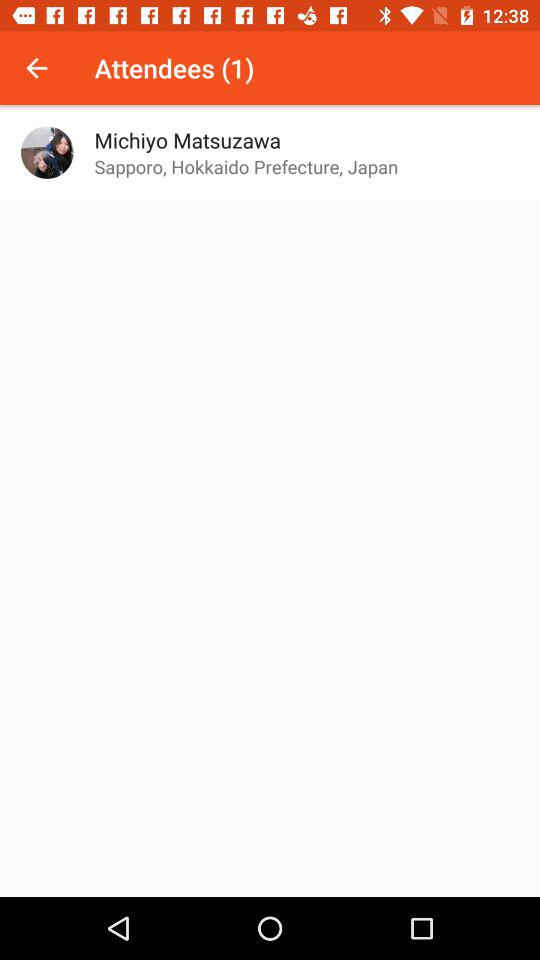How many attendees are there?
Answer the question using a single word or phrase. 1 